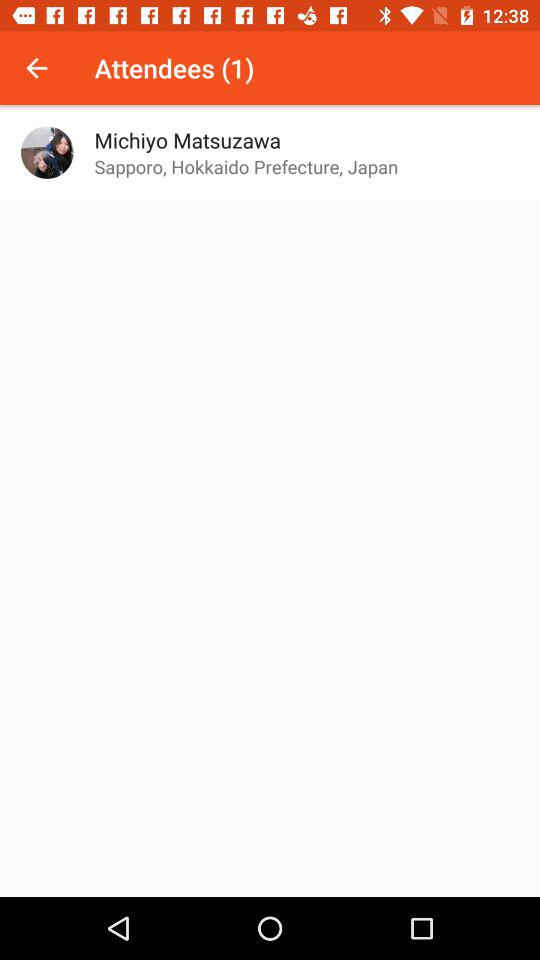How many attendees are there?
Answer the question using a single word or phrase. 1 